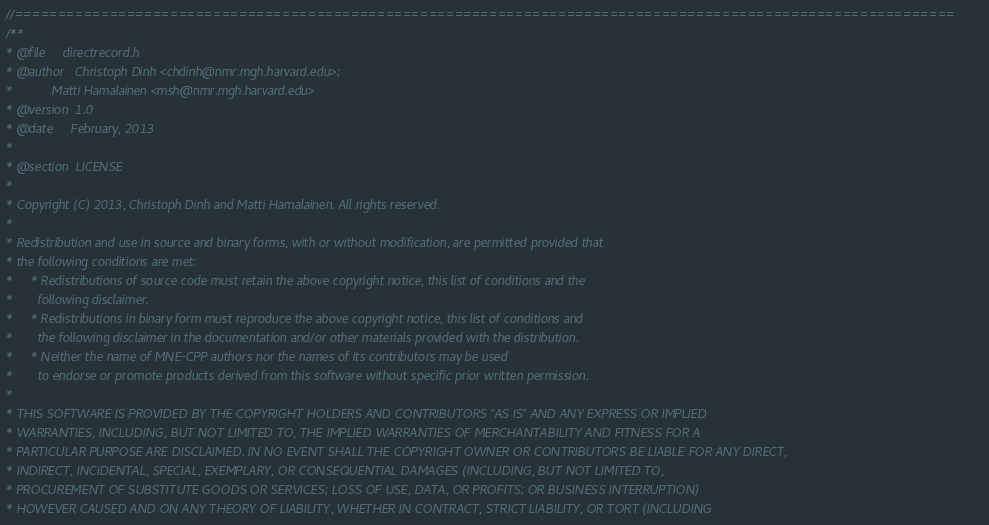Convert code to text. <code><loc_0><loc_0><loc_500><loc_500><_C_>//=============================================================================================================
/**
* @file     directrecord.h
* @author   Christoph Dinh <chdinh@nmr.mgh.harvard.edu>;
*           Matti Hamalainen <msh@nmr.mgh.harvard.edu>
* @version  1.0
* @date     February, 2013
*
* @section  LICENSE
*
* Copyright (C) 2013, Christoph Dinh and Matti Hamalainen. All rights reserved.
*
* Redistribution and use in source and binary forms, with or without modification, are permitted provided that
* the following conditions are met:
*     * Redistributions of source code must retain the above copyright notice, this list of conditions and the
*       following disclaimer.
*     * Redistributions in binary form must reproduce the above copyright notice, this list of conditions and
*       the following disclaimer in the documentation and/or other materials provided with the distribution.
*     * Neither the name of MNE-CPP authors nor the names of its contributors may be used
*       to endorse or promote products derived from this software without specific prior written permission.
*
* THIS SOFTWARE IS PROVIDED BY THE COPYRIGHT HOLDERS AND CONTRIBUTORS "AS IS" AND ANY EXPRESS OR IMPLIED
* WARRANTIES, INCLUDING, BUT NOT LIMITED TO, THE IMPLIED WARRANTIES OF MERCHANTABILITY AND FITNESS FOR A
* PARTICULAR PURPOSE ARE DISCLAIMED. IN NO EVENT SHALL THE COPYRIGHT OWNER OR CONTRIBUTORS BE LIABLE FOR ANY DIRECT,
* INDIRECT, INCIDENTAL, SPECIAL, EXEMPLARY, OR CONSEQUENTIAL DAMAGES (INCLUDING, BUT NOT LIMITED TO,
* PROCUREMENT OF SUBSTITUTE GOODS OR SERVICES; LOSS OF USE, DATA, OR PROFITS; OR BUSINESS INTERRUPTION)
* HOWEVER CAUSED AND ON ANY THEORY OF LIABILITY, WHETHER IN CONTRACT, STRICT LIABILITY, OR TORT (INCLUDING</code> 